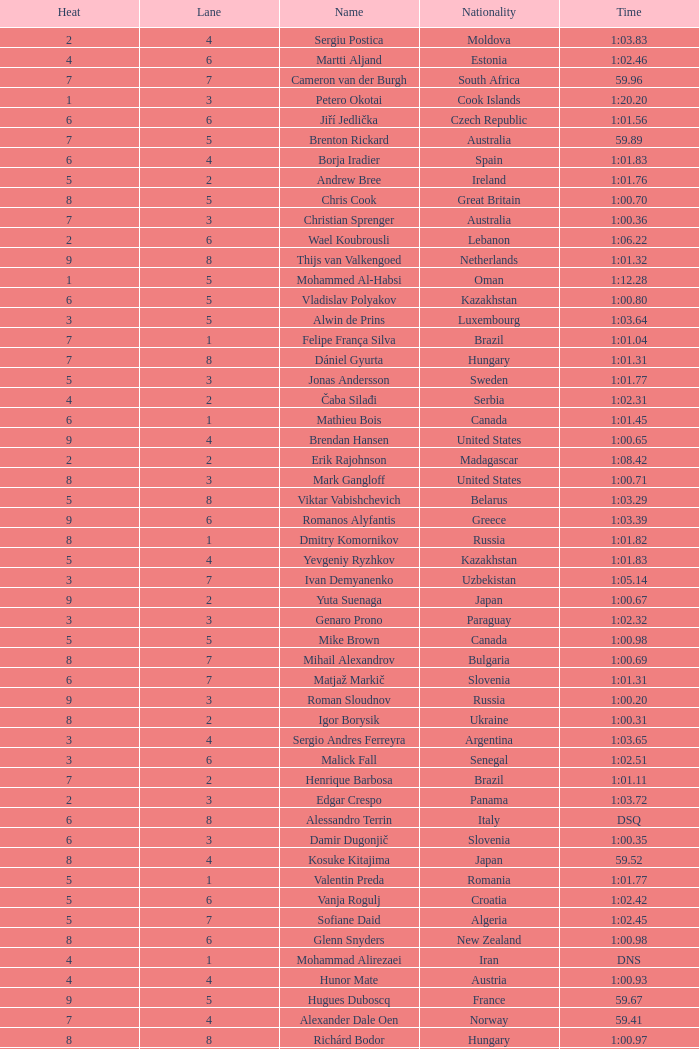What is the time in a heat smaller than 5, in Lane 5, for Vietnam? 1:06.36. 